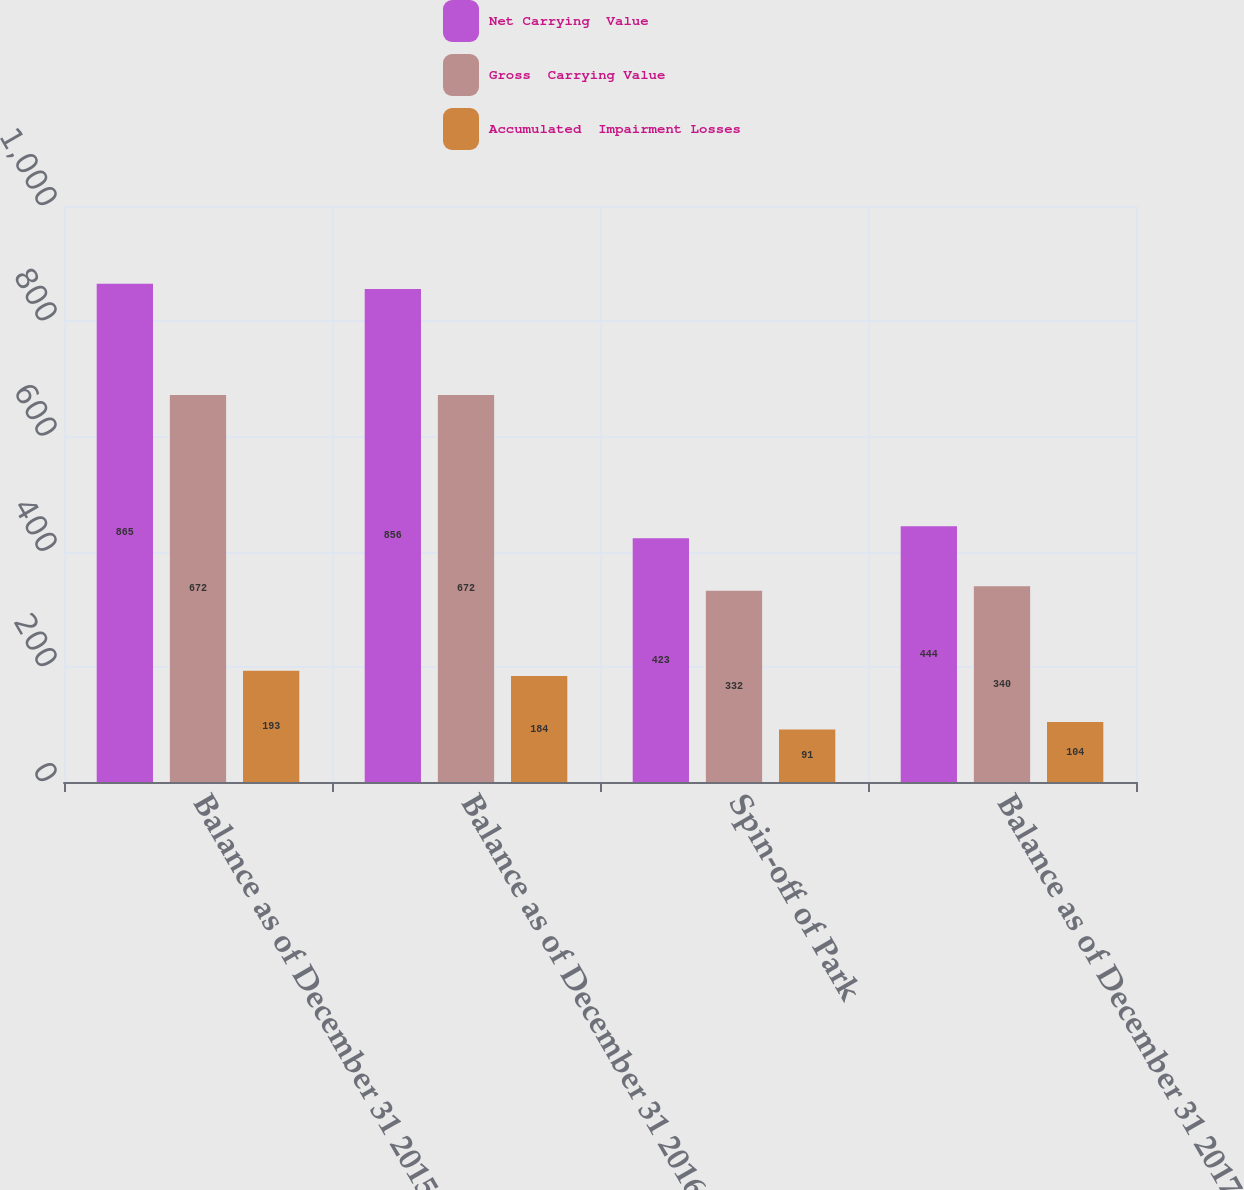Convert chart. <chart><loc_0><loc_0><loc_500><loc_500><stacked_bar_chart><ecel><fcel>Balance as of December 31 2015<fcel>Balance as of December 31 2016<fcel>Spin-off of Park<fcel>Balance as of December 31 2017<nl><fcel>Net Carrying  Value<fcel>865<fcel>856<fcel>423<fcel>444<nl><fcel>Gross  Carrying Value<fcel>672<fcel>672<fcel>332<fcel>340<nl><fcel>Accumulated  Impairment Losses<fcel>193<fcel>184<fcel>91<fcel>104<nl></chart> 